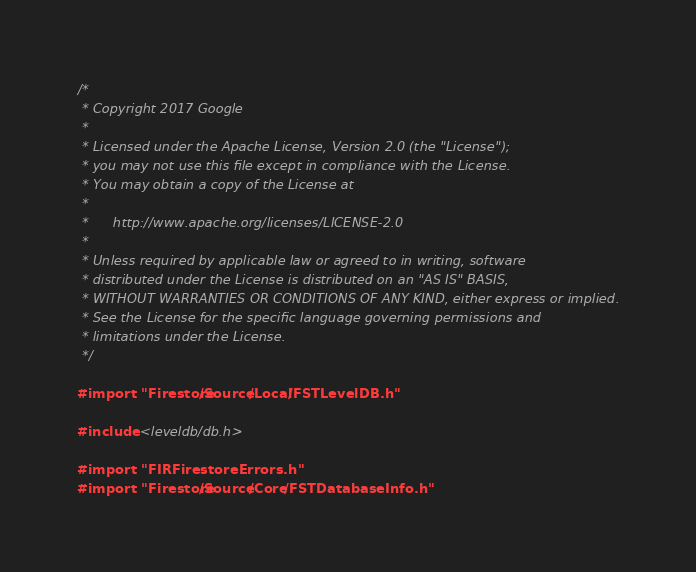<code> <loc_0><loc_0><loc_500><loc_500><_ObjectiveC_>/*
 * Copyright 2017 Google
 *
 * Licensed under the Apache License, Version 2.0 (the "License");
 * you may not use this file except in compliance with the License.
 * You may obtain a copy of the License at
 *
 *      http://www.apache.org/licenses/LICENSE-2.0
 *
 * Unless required by applicable law or agreed to in writing, software
 * distributed under the License is distributed on an "AS IS" BASIS,
 * WITHOUT WARRANTIES OR CONDITIONS OF ANY KIND, either express or implied.
 * See the License for the specific language governing permissions and
 * limitations under the License.
 */

#import "Firestore/Source/Local/FSTLevelDB.h"

#include <leveldb/db.h>

#import "FIRFirestoreErrors.h"
#import "Firestore/Source/Core/FSTDatabaseInfo.h"</code> 